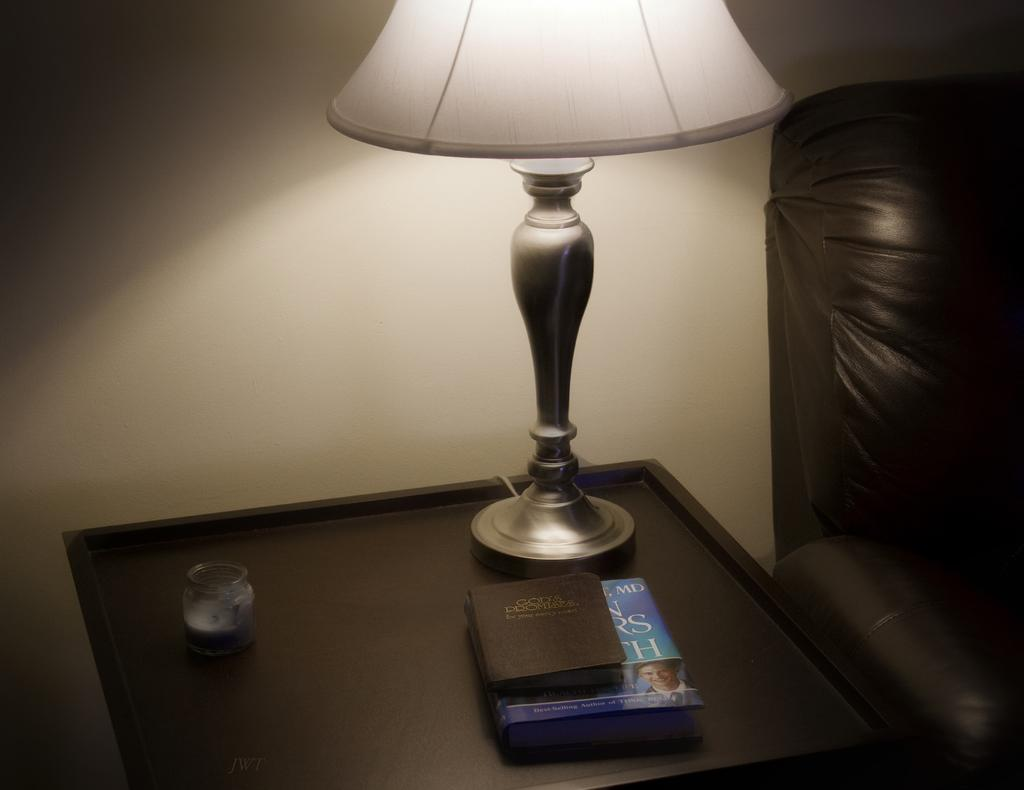What objects are on the table in the image? There are books, a lantern-lamp, and a jar on the table in the image. What type of lighting is present on the table? There is a lantern-lamp on the table. What piece of furniture is located beside the table? There is a couch beside the table. What type of cable is connected to the books on the table? There is no cable connected to the books on the table in the image. What date is marked on the calendar on the table? There is no calendar present in the image; it only features books, a lantern-lamp, and a jar on the table. 